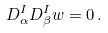<formula> <loc_0><loc_0><loc_500><loc_500>D ^ { I } _ { \alpha } D ^ { I } _ { \beta } w = 0 \, .</formula> 